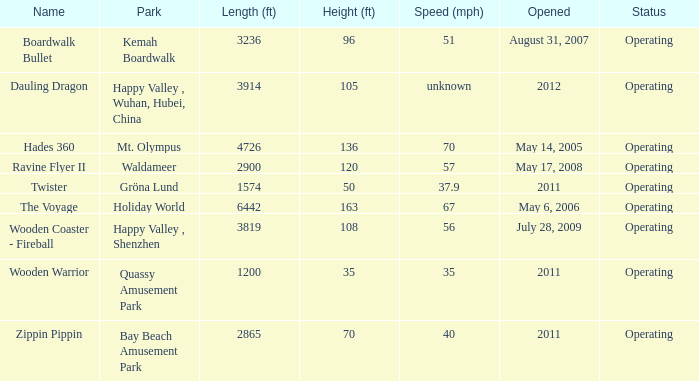What is the roller coaster's distance at kemah boardwalk? 3236.0. 